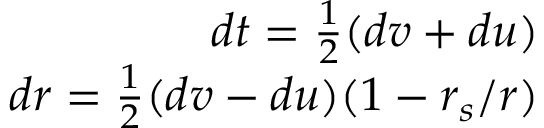Convert formula to latex. <formula><loc_0><loc_0><loc_500><loc_500>\begin{array} { r } { d t = \frac { 1 } { 2 } ( d v + d u ) } \\ { d r = \frac { 1 } { 2 } ( d v - d u ) ( 1 - r _ { s } / r ) } \end{array}</formula> 